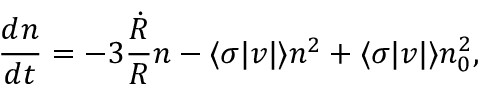Convert formula to latex. <formula><loc_0><loc_0><loc_500><loc_500>{ \frac { d n } { d t } } = - 3 { \frac { \dot { R } } { R } } n - \langle \sigma | v | \rangle n ^ { 2 } + \langle \sigma | v | \rangle n _ { 0 } ^ { 2 } ,</formula> 